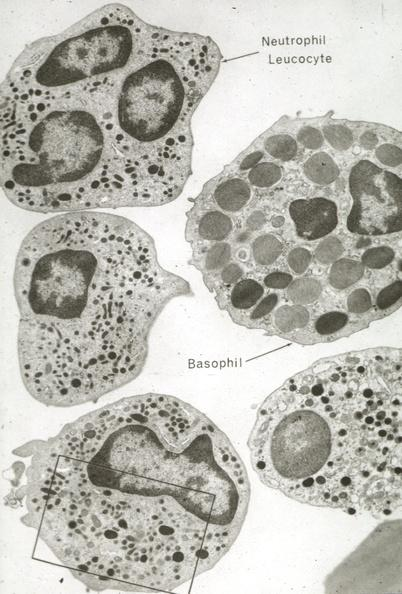does parathyroid show neutrophils and basophil?
Answer the question using a single word or phrase. No 